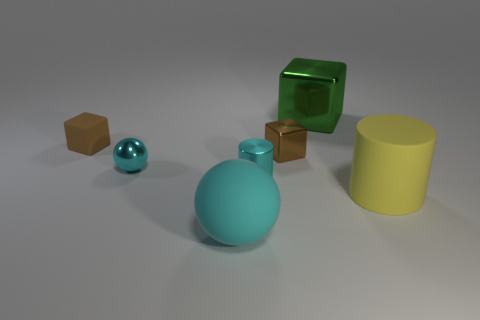What is the lighting like in the scene? The lighting in the scene is soft and diffused, coming from overhead. There are subtle shadows under each object, indicating that the light source is not directly above but slightly off to the side. 